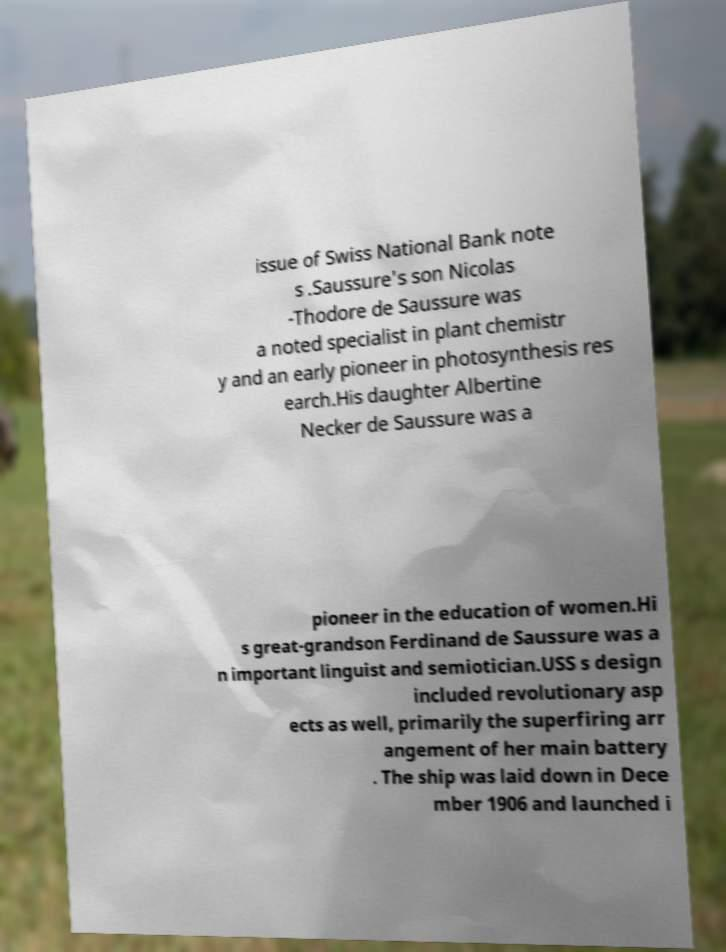Please identify and transcribe the text found in this image. issue of Swiss National Bank note s .Saussure's son Nicolas -Thodore de Saussure was a noted specialist in plant chemistr y and an early pioneer in photosynthesis res earch.His daughter Albertine Necker de Saussure was a pioneer in the education of women.Hi s great-grandson Ferdinand de Saussure was a n important linguist and semiotician.USS s design included revolutionary asp ects as well, primarily the superfiring arr angement of her main battery . The ship was laid down in Dece mber 1906 and launched i 